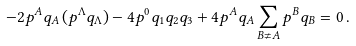Convert formula to latex. <formula><loc_0><loc_0><loc_500><loc_500>- 2 p ^ { A } q _ { A } \, ( p ^ { \Lambda } q _ { \Lambda } ) - 4 p ^ { 0 } q _ { 1 } q _ { 2 } q _ { 3 } + 4 p ^ { A } q _ { A } \sum _ { B \neq A } p ^ { B } q _ { B } = 0 \, .</formula> 